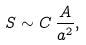Convert formula to latex. <formula><loc_0><loc_0><loc_500><loc_500>S \sim C \, \frac { A } { a ^ { 2 } } ,</formula> 